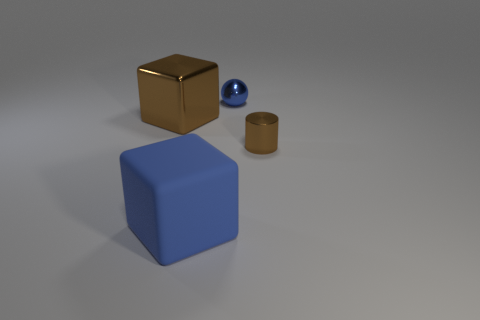How many large things are either brown blocks or blue blocks? There are two large blocks in the image, one is a brown cube and the other is a blue cube. Despite the presence of smaller objects, only these cubes fit the description of large, colored blocks. 